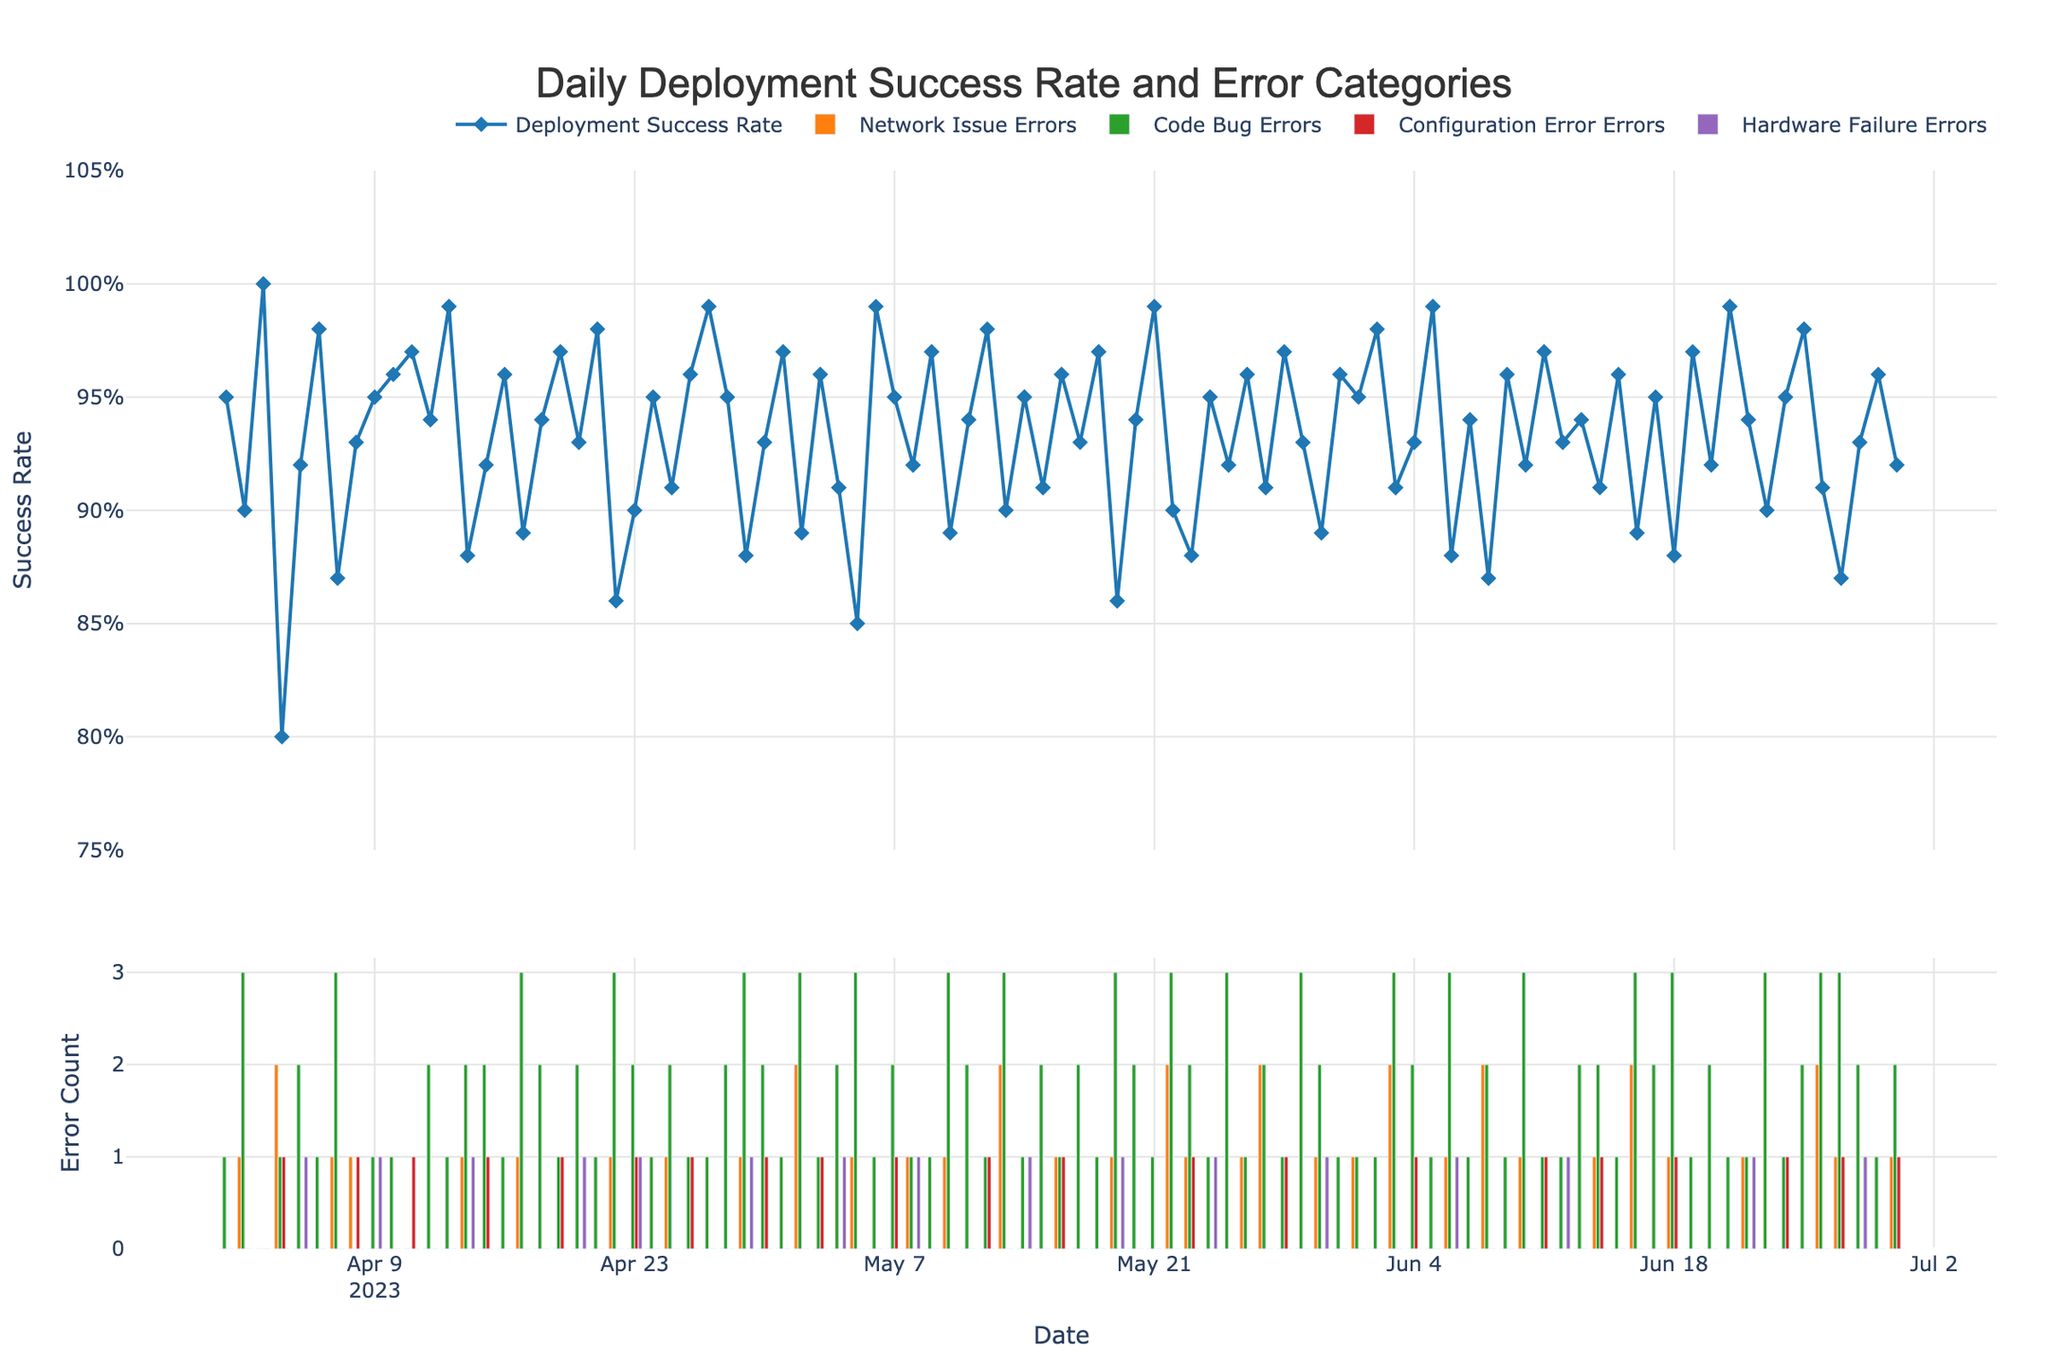What is the title of the figure? The title is clearly displayed at the top of the figure. It summarizes what the figure is about.
Answer: Daily Deployment Success Rate and Error Categories What is the range of the Y-axis for the Success Rate in the figure? The Y-axis for the Success Rate, which is found on the left side of the top subplot, ranges from 0.75 to 1.05.
Answer: 0.75 to 1.05 How many categories of errors are plotted in the figure? The figure includes four distinct categories of errors marked by differently colored bars in the bottom subplot. You can count the legend entries or the different colors of bars.
Answer: Four On which date did the Deployment Success Rate drop below 0.85 for the first time in the plot? By examining the deployment success rate trend line on the top subplot, find the first date the rate drops below 0.85. Specifically, this occurs on May 5.
Answer: May 5 What is the total count of code bug errors on June 10? Look at the bar representing the code bug errors for June 10, which is found by finding the corresponding bar color in the legend and reading its height.
Answer: Three What is the average deployment success rate for June 2023? Locate all the success rate points for June and calculate the average of these values. They are 0.95, 0.92, 0.99, 0.94, 0.90, 0.95, 0.98, 0.91, 0.87, 0.93, 0.96, 0.92. Adding these gives \(0.95+0.92+0.99+0.94+0.90+0.95+0.98+0.91+0.87+0.93+0.96+0.92 = 11.22\). There are 12 values, so the average is \(11.22/12 = 0.935\).
Answer: 0.935 Compare the config error counts for April 4 and June 30. Which day has more config errors and by how much? Locate both dates on the horizontal axis in the bottom subplot, compare the heights of the respective bars for the configuration errors, and subtract the smaller value from the larger one. April 4 has 1 and June 30 has 1. The difference is 0.
Answer: Both have the same count, 0 difference Which category had the most errors on April 22, and what was the count? Find April 22 on the x-axis of the bottom subplot and compare the heights of the bars to determine which one is the tallest and its height. For April 22, network issue errors had 1, code bug errors had 3, configuration errors had 0, and hardware failures had 0. The Code Bug Errors are the highest with a count of 3.
Answer: Code Bug Errors, 3 Across the entire data range, which error category had the maximum single-day count, and what was the count? Look through the bottom subplot to find the highest individual bar and note its corresponding error category and its height. The highest single-day count is 3, which appears multiple times for code bug errors.
Answer: Code Bug Errors, 3 